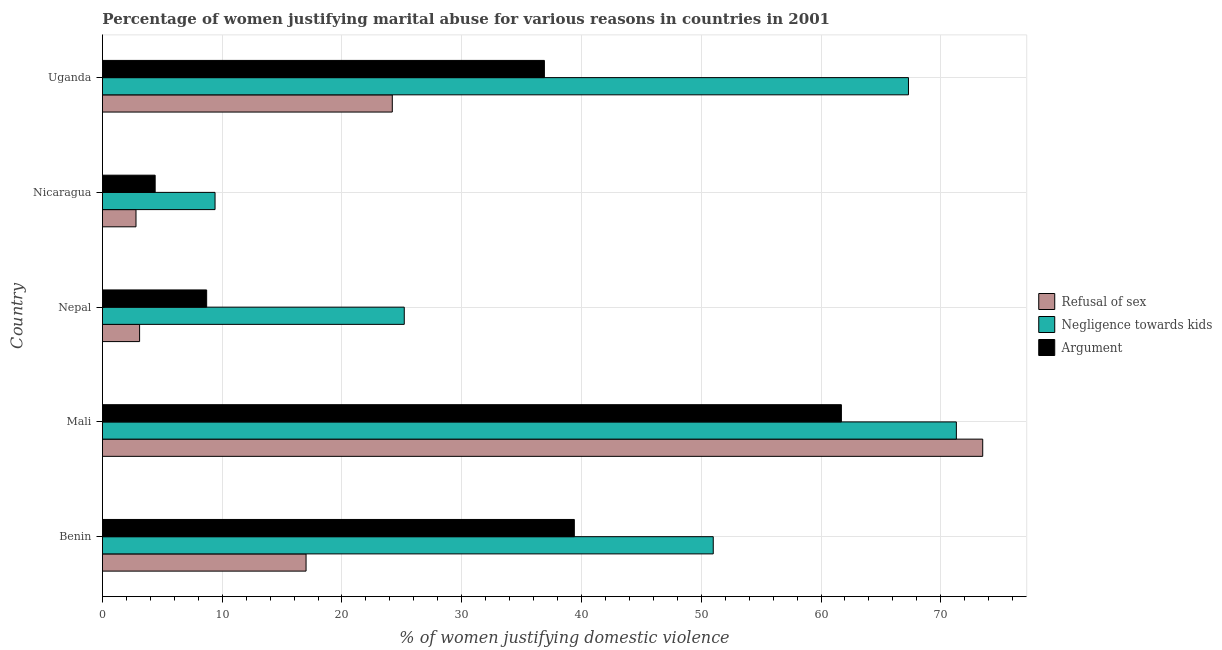Are the number of bars on each tick of the Y-axis equal?
Your answer should be compact. Yes. How many bars are there on the 2nd tick from the top?
Ensure brevity in your answer.  3. What is the label of the 4th group of bars from the top?
Your answer should be compact. Mali. What is the percentage of women justifying domestic violence due to negligence towards kids in Nicaragua?
Your answer should be very brief. 9.4. Across all countries, what is the maximum percentage of women justifying domestic violence due to arguments?
Make the answer very short. 61.7. In which country was the percentage of women justifying domestic violence due to refusal of sex maximum?
Ensure brevity in your answer.  Mali. In which country was the percentage of women justifying domestic violence due to refusal of sex minimum?
Provide a short and direct response. Nicaragua. What is the total percentage of women justifying domestic violence due to negligence towards kids in the graph?
Provide a short and direct response. 224.2. What is the difference between the percentage of women justifying domestic violence due to arguments in Mali and that in Nicaragua?
Your answer should be very brief. 57.3. What is the difference between the percentage of women justifying domestic violence due to arguments in Uganda and the percentage of women justifying domestic violence due to refusal of sex in Nepal?
Your answer should be very brief. 33.8. What is the average percentage of women justifying domestic violence due to refusal of sex per country?
Offer a terse response. 24.12. What is the ratio of the percentage of women justifying domestic violence due to negligence towards kids in Benin to that in Mali?
Offer a terse response. 0.71. What is the difference between the highest and the second highest percentage of women justifying domestic violence due to arguments?
Keep it short and to the point. 22.3. What is the difference between the highest and the lowest percentage of women justifying domestic violence due to negligence towards kids?
Ensure brevity in your answer.  61.9. What does the 3rd bar from the top in Benin represents?
Offer a very short reply. Refusal of sex. What does the 2nd bar from the bottom in Uganda represents?
Provide a succinct answer. Negligence towards kids. Are the values on the major ticks of X-axis written in scientific E-notation?
Make the answer very short. No. Does the graph contain any zero values?
Make the answer very short. No. Where does the legend appear in the graph?
Ensure brevity in your answer.  Center right. How are the legend labels stacked?
Offer a terse response. Vertical. What is the title of the graph?
Ensure brevity in your answer.  Percentage of women justifying marital abuse for various reasons in countries in 2001. What is the label or title of the X-axis?
Ensure brevity in your answer.  % of women justifying domestic violence. What is the % of women justifying domestic violence of Refusal of sex in Benin?
Give a very brief answer. 17. What is the % of women justifying domestic violence of Negligence towards kids in Benin?
Your answer should be compact. 51. What is the % of women justifying domestic violence in Argument in Benin?
Your answer should be compact. 39.4. What is the % of women justifying domestic violence of Refusal of sex in Mali?
Your answer should be compact. 73.5. What is the % of women justifying domestic violence in Negligence towards kids in Mali?
Make the answer very short. 71.3. What is the % of women justifying domestic violence in Argument in Mali?
Give a very brief answer. 61.7. What is the % of women justifying domestic violence in Negligence towards kids in Nepal?
Provide a succinct answer. 25.2. What is the % of women justifying domestic violence of Refusal of sex in Uganda?
Provide a succinct answer. 24.2. What is the % of women justifying domestic violence of Negligence towards kids in Uganda?
Offer a very short reply. 67.3. What is the % of women justifying domestic violence in Argument in Uganda?
Your response must be concise. 36.9. Across all countries, what is the maximum % of women justifying domestic violence in Refusal of sex?
Keep it short and to the point. 73.5. Across all countries, what is the maximum % of women justifying domestic violence in Negligence towards kids?
Your answer should be very brief. 71.3. Across all countries, what is the maximum % of women justifying domestic violence in Argument?
Ensure brevity in your answer.  61.7. Across all countries, what is the minimum % of women justifying domestic violence of Negligence towards kids?
Make the answer very short. 9.4. What is the total % of women justifying domestic violence of Refusal of sex in the graph?
Offer a very short reply. 120.6. What is the total % of women justifying domestic violence of Negligence towards kids in the graph?
Your response must be concise. 224.2. What is the total % of women justifying domestic violence in Argument in the graph?
Offer a very short reply. 151.1. What is the difference between the % of women justifying domestic violence of Refusal of sex in Benin and that in Mali?
Your answer should be compact. -56.5. What is the difference between the % of women justifying domestic violence of Negligence towards kids in Benin and that in Mali?
Your answer should be compact. -20.3. What is the difference between the % of women justifying domestic violence in Argument in Benin and that in Mali?
Keep it short and to the point. -22.3. What is the difference between the % of women justifying domestic violence in Refusal of sex in Benin and that in Nepal?
Your response must be concise. 13.9. What is the difference between the % of women justifying domestic violence of Negligence towards kids in Benin and that in Nepal?
Offer a terse response. 25.8. What is the difference between the % of women justifying domestic violence of Argument in Benin and that in Nepal?
Make the answer very short. 30.7. What is the difference between the % of women justifying domestic violence in Negligence towards kids in Benin and that in Nicaragua?
Offer a very short reply. 41.6. What is the difference between the % of women justifying domestic violence of Argument in Benin and that in Nicaragua?
Ensure brevity in your answer.  35. What is the difference between the % of women justifying domestic violence of Negligence towards kids in Benin and that in Uganda?
Your answer should be very brief. -16.3. What is the difference between the % of women justifying domestic violence in Refusal of sex in Mali and that in Nepal?
Give a very brief answer. 70.4. What is the difference between the % of women justifying domestic violence of Negligence towards kids in Mali and that in Nepal?
Give a very brief answer. 46.1. What is the difference between the % of women justifying domestic violence in Refusal of sex in Mali and that in Nicaragua?
Make the answer very short. 70.7. What is the difference between the % of women justifying domestic violence in Negligence towards kids in Mali and that in Nicaragua?
Offer a terse response. 61.9. What is the difference between the % of women justifying domestic violence in Argument in Mali and that in Nicaragua?
Offer a very short reply. 57.3. What is the difference between the % of women justifying domestic violence of Refusal of sex in Mali and that in Uganda?
Your response must be concise. 49.3. What is the difference between the % of women justifying domestic violence of Argument in Mali and that in Uganda?
Your answer should be compact. 24.8. What is the difference between the % of women justifying domestic violence of Refusal of sex in Nepal and that in Nicaragua?
Keep it short and to the point. 0.3. What is the difference between the % of women justifying domestic violence of Refusal of sex in Nepal and that in Uganda?
Your answer should be very brief. -21.1. What is the difference between the % of women justifying domestic violence in Negligence towards kids in Nepal and that in Uganda?
Your response must be concise. -42.1. What is the difference between the % of women justifying domestic violence in Argument in Nepal and that in Uganda?
Your answer should be very brief. -28.2. What is the difference between the % of women justifying domestic violence in Refusal of sex in Nicaragua and that in Uganda?
Your answer should be compact. -21.4. What is the difference between the % of women justifying domestic violence in Negligence towards kids in Nicaragua and that in Uganda?
Your response must be concise. -57.9. What is the difference between the % of women justifying domestic violence in Argument in Nicaragua and that in Uganda?
Provide a short and direct response. -32.5. What is the difference between the % of women justifying domestic violence in Refusal of sex in Benin and the % of women justifying domestic violence in Negligence towards kids in Mali?
Provide a short and direct response. -54.3. What is the difference between the % of women justifying domestic violence in Refusal of sex in Benin and the % of women justifying domestic violence in Argument in Mali?
Give a very brief answer. -44.7. What is the difference between the % of women justifying domestic violence in Negligence towards kids in Benin and the % of women justifying domestic violence in Argument in Mali?
Your answer should be compact. -10.7. What is the difference between the % of women justifying domestic violence of Negligence towards kids in Benin and the % of women justifying domestic violence of Argument in Nepal?
Provide a succinct answer. 42.3. What is the difference between the % of women justifying domestic violence in Refusal of sex in Benin and the % of women justifying domestic violence in Negligence towards kids in Nicaragua?
Ensure brevity in your answer.  7.6. What is the difference between the % of women justifying domestic violence of Refusal of sex in Benin and the % of women justifying domestic violence of Argument in Nicaragua?
Ensure brevity in your answer.  12.6. What is the difference between the % of women justifying domestic violence of Negligence towards kids in Benin and the % of women justifying domestic violence of Argument in Nicaragua?
Make the answer very short. 46.6. What is the difference between the % of women justifying domestic violence in Refusal of sex in Benin and the % of women justifying domestic violence in Negligence towards kids in Uganda?
Provide a succinct answer. -50.3. What is the difference between the % of women justifying domestic violence in Refusal of sex in Benin and the % of women justifying domestic violence in Argument in Uganda?
Make the answer very short. -19.9. What is the difference between the % of women justifying domestic violence of Negligence towards kids in Benin and the % of women justifying domestic violence of Argument in Uganda?
Offer a terse response. 14.1. What is the difference between the % of women justifying domestic violence in Refusal of sex in Mali and the % of women justifying domestic violence in Negligence towards kids in Nepal?
Give a very brief answer. 48.3. What is the difference between the % of women justifying domestic violence of Refusal of sex in Mali and the % of women justifying domestic violence of Argument in Nepal?
Your answer should be compact. 64.8. What is the difference between the % of women justifying domestic violence of Negligence towards kids in Mali and the % of women justifying domestic violence of Argument in Nepal?
Keep it short and to the point. 62.6. What is the difference between the % of women justifying domestic violence in Refusal of sex in Mali and the % of women justifying domestic violence in Negligence towards kids in Nicaragua?
Your response must be concise. 64.1. What is the difference between the % of women justifying domestic violence of Refusal of sex in Mali and the % of women justifying domestic violence of Argument in Nicaragua?
Offer a very short reply. 69.1. What is the difference between the % of women justifying domestic violence of Negligence towards kids in Mali and the % of women justifying domestic violence of Argument in Nicaragua?
Offer a very short reply. 66.9. What is the difference between the % of women justifying domestic violence in Refusal of sex in Mali and the % of women justifying domestic violence in Argument in Uganda?
Offer a terse response. 36.6. What is the difference between the % of women justifying domestic violence of Negligence towards kids in Mali and the % of women justifying domestic violence of Argument in Uganda?
Keep it short and to the point. 34.4. What is the difference between the % of women justifying domestic violence of Refusal of sex in Nepal and the % of women justifying domestic violence of Negligence towards kids in Nicaragua?
Give a very brief answer. -6.3. What is the difference between the % of women justifying domestic violence in Refusal of sex in Nepal and the % of women justifying domestic violence in Argument in Nicaragua?
Make the answer very short. -1.3. What is the difference between the % of women justifying domestic violence of Negligence towards kids in Nepal and the % of women justifying domestic violence of Argument in Nicaragua?
Offer a very short reply. 20.8. What is the difference between the % of women justifying domestic violence of Refusal of sex in Nepal and the % of women justifying domestic violence of Negligence towards kids in Uganda?
Keep it short and to the point. -64.2. What is the difference between the % of women justifying domestic violence of Refusal of sex in Nepal and the % of women justifying domestic violence of Argument in Uganda?
Your answer should be compact. -33.8. What is the difference between the % of women justifying domestic violence of Refusal of sex in Nicaragua and the % of women justifying domestic violence of Negligence towards kids in Uganda?
Your response must be concise. -64.5. What is the difference between the % of women justifying domestic violence of Refusal of sex in Nicaragua and the % of women justifying domestic violence of Argument in Uganda?
Ensure brevity in your answer.  -34.1. What is the difference between the % of women justifying domestic violence in Negligence towards kids in Nicaragua and the % of women justifying domestic violence in Argument in Uganda?
Ensure brevity in your answer.  -27.5. What is the average % of women justifying domestic violence of Refusal of sex per country?
Your response must be concise. 24.12. What is the average % of women justifying domestic violence in Negligence towards kids per country?
Give a very brief answer. 44.84. What is the average % of women justifying domestic violence of Argument per country?
Ensure brevity in your answer.  30.22. What is the difference between the % of women justifying domestic violence in Refusal of sex and % of women justifying domestic violence in Negligence towards kids in Benin?
Make the answer very short. -34. What is the difference between the % of women justifying domestic violence of Refusal of sex and % of women justifying domestic violence of Argument in Benin?
Ensure brevity in your answer.  -22.4. What is the difference between the % of women justifying domestic violence in Negligence towards kids and % of women justifying domestic violence in Argument in Benin?
Offer a terse response. 11.6. What is the difference between the % of women justifying domestic violence in Refusal of sex and % of women justifying domestic violence in Negligence towards kids in Mali?
Your response must be concise. 2.2. What is the difference between the % of women justifying domestic violence of Refusal of sex and % of women justifying domestic violence of Argument in Mali?
Provide a short and direct response. 11.8. What is the difference between the % of women justifying domestic violence in Refusal of sex and % of women justifying domestic violence in Negligence towards kids in Nepal?
Provide a short and direct response. -22.1. What is the difference between the % of women justifying domestic violence of Negligence towards kids and % of women justifying domestic violence of Argument in Nepal?
Provide a short and direct response. 16.5. What is the difference between the % of women justifying domestic violence of Refusal of sex and % of women justifying domestic violence of Negligence towards kids in Nicaragua?
Ensure brevity in your answer.  -6.6. What is the difference between the % of women justifying domestic violence of Negligence towards kids and % of women justifying domestic violence of Argument in Nicaragua?
Ensure brevity in your answer.  5. What is the difference between the % of women justifying domestic violence in Refusal of sex and % of women justifying domestic violence in Negligence towards kids in Uganda?
Your answer should be very brief. -43.1. What is the difference between the % of women justifying domestic violence of Refusal of sex and % of women justifying domestic violence of Argument in Uganda?
Provide a succinct answer. -12.7. What is the difference between the % of women justifying domestic violence in Negligence towards kids and % of women justifying domestic violence in Argument in Uganda?
Make the answer very short. 30.4. What is the ratio of the % of women justifying domestic violence of Refusal of sex in Benin to that in Mali?
Keep it short and to the point. 0.23. What is the ratio of the % of women justifying domestic violence of Negligence towards kids in Benin to that in Mali?
Keep it short and to the point. 0.72. What is the ratio of the % of women justifying domestic violence in Argument in Benin to that in Mali?
Your answer should be compact. 0.64. What is the ratio of the % of women justifying domestic violence of Refusal of sex in Benin to that in Nepal?
Offer a very short reply. 5.48. What is the ratio of the % of women justifying domestic violence in Negligence towards kids in Benin to that in Nepal?
Provide a short and direct response. 2.02. What is the ratio of the % of women justifying domestic violence in Argument in Benin to that in Nepal?
Keep it short and to the point. 4.53. What is the ratio of the % of women justifying domestic violence in Refusal of sex in Benin to that in Nicaragua?
Your response must be concise. 6.07. What is the ratio of the % of women justifying domestic violence in Negligence towards kids in Benin to that in Nicaragua?
Provide a short and direct response. 5.43. What is the ratio of the % of women justifying domestic violence in Argument in Benin to that in Nicaragua?
Your answer should be compact. 8.95. What is the ratio of the % of women justifying domestic violence in Refusal of sex in Benin to that in Uganda?
Offer a terse response. 0.7. What is the ratio of the % of women justifying domestic violence of Negligence towards kids in Benin to that in Uganda?
Your answer should be very brief. 0.76. What is the ratio of the % of women justifying domestic violence in Argument in Benin to that in Uganda?
Your answer should be compact. 1.07. What is the ratio of the % of women justifying domestic violence in Refusal of sex in Mali to that in Nepal?
Keep it short and to the point. 23.71. What is the ratio of the % of women justifying domestic violence of Negligence towards kids in Mali to that in Nepal?
Offer a terse response. 2.83. What is the ratio of the % of women justifying domestic violence of Argument in Mali to that in Nepal?
Your response must be concise. 7.09. What is the ratio of the % of women justifying domestic violence in Refusal of sex in Mali to that in Nicaragua?
Offer a very short reply. 26.25. What is the ratio of the % of women justifying domestic violence of Negligence towards kids in Mali to that in Nicaragua?
Provide a succinct answer. 7.59. What is the ratio of the % of women justifying domestic violence of Argument in Mali to that in Nicaragua?
Your answer should be compact. 14.02. What is the ratio of the % of women justifying domestic violence in Refusal of sex in Mali to that in Uganda?
Provide a succinct answer. 3.04. What is the ratio of the % of women justifying domestic violence of Negligence towards kids in Mali to that in Uganda?
Provide a succinct answer. 1.06. What is the ratio of the % of women justifying domestic violence of Argument in Mali to that in Uganda?
Offer a very short reply. 1.67. What is the ratio of the % of women justifying domestic violence in Refusal of sex in Nepal to that in Nicaragua?
Your answer should be very brief. 1.11. What is the ratio of the % of women justifying domestic violence of Negligence towards kids in Nepal to that in Nicaragua?
Offer a terse response. 2.68. What is the ratio of the % of women justifying domestic violence in Argument in Nepal to that in Nicaragua?
Make the answer very short. 1.98. What is the ratio of the % of women justifying domestic violence in Refusal of sex in Nepal to that in Uganda?
Your answer should be very brief. 0.13. What is the ratio of the % of women justifying domestic violence in Negligence towards kids in Nepal to that in Uganda?
Give a very brief answer. 0.37. What is the ratio of the % of women justifying domestic violence of Argument in Nepal to that in Uganda?
Keep it short and to the point. 0.24. What is the ratio of the % of women justifying domestic violence in Refusal of sex in Nicaragua to that in Uganda?
Give a very brief answer. 0.12. What is the ratio of the % of women justifying domestic violence of Negligence towards kids in Nicaragua to that in Uganda?
Make the answer very short. 0.14. What is the ratio of the % of women justifying domestic violence in Argument in Nicaragua to that in Uganda?
Make the answer very short. 0.12. What is the difference between the highest and the second highest % of women justifying domestic violence in Refusal of sex?
Offer a terse response. 49.3. What is the difference between the highest and the second highest % of women justifying domestic violence in Negligence towards kids?
Your answer should be very brief. 4. What is the difference between the highest and the second highest % of women justifying domestic violence of Argument?
Make the answer very short. 22.3. What is the difference between the highest and the lowest % of women justifying domestic violence of Refusal of sex?
Offer a terse response. 70.7. What is the difference between the highest and the lowest % of women justifying domestic violence in Negligence towards kids?
Offer a terse response. 61.9. What is the difference between the highest and the lowest % of women justifying domestic violence in Argument?
Your answer should be compact. 57.3. 